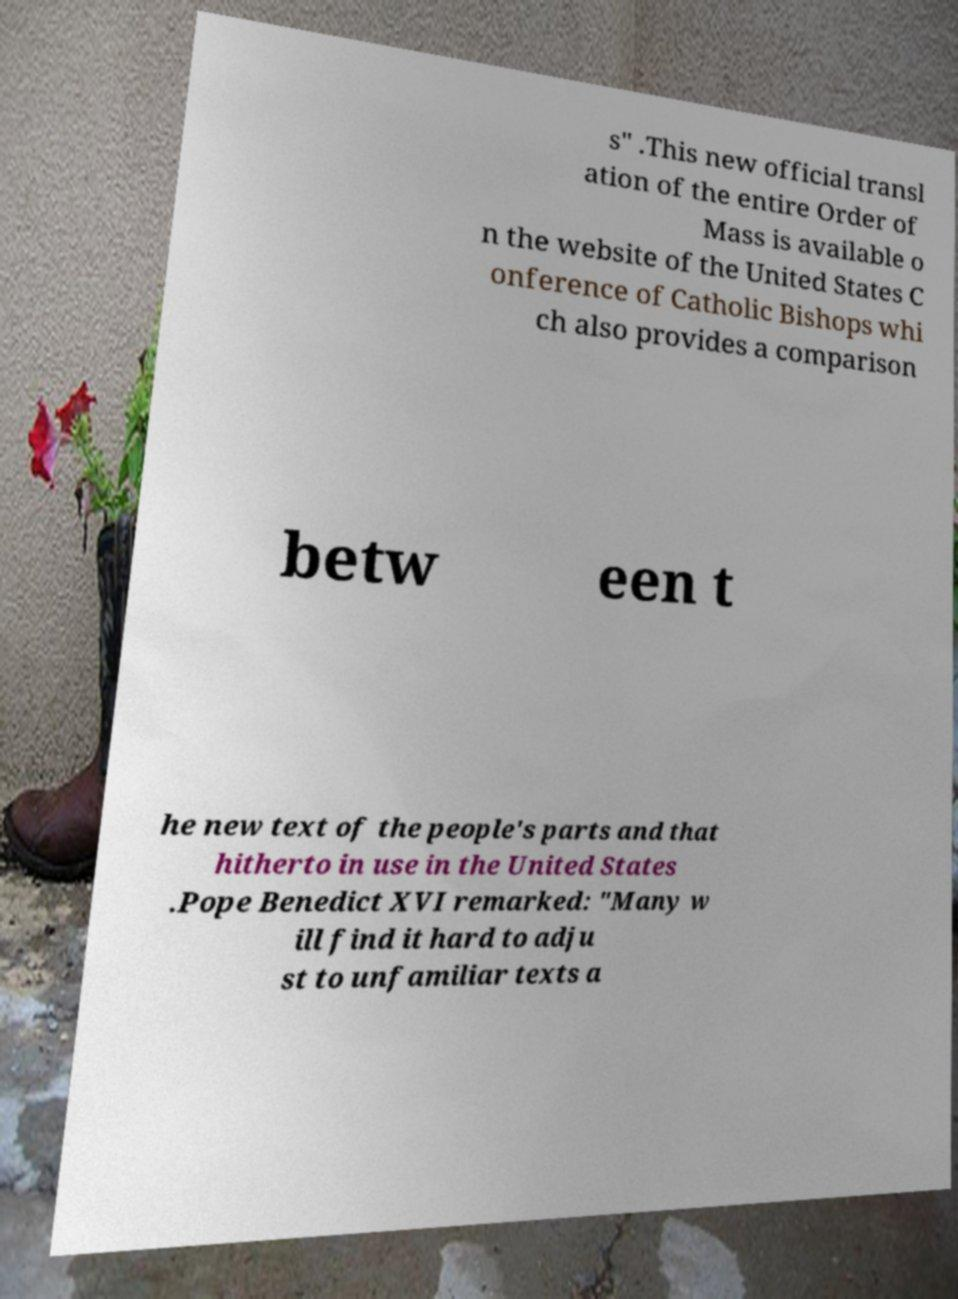Can you read and provide the text displayed in the image?This photo seems to have some interesting text. Can you extract and type it out for me? s" .This new official transl ation of the entire Order of Mass is available o n the website of the United States C onference of Catholic Bishops whi ch also provides a comparison betw een t he new text of the people's parts and that hitherto in use in the United States .Pope Benedict XVI remarked: "Many w ill find it hard to adju st to unfamiliar texts a 